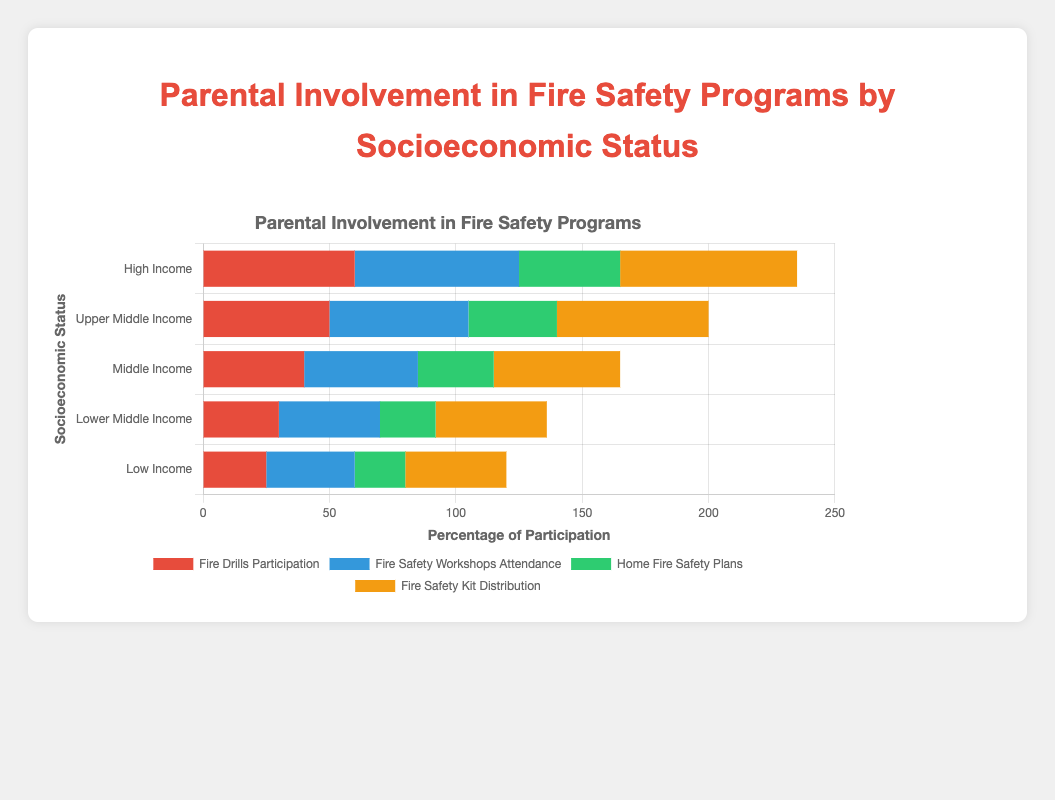Which socioeconomic status group has the highest participation in Fire Drills? Look at the data for Fire Drills Participation in the chart. The highest value is for High Income with a participation rate of 60%.
Answer: High Income Which activity has the most parental involvement across all socioeconomic statuses? To find the activity with the most involvement, sum the participation rates of each activity across all groups: Fire Drills (25+30+40+50+60), Fire Safety Workshops (35+40+45+55+65), Home Fire Safety Plans (20+22+30+35+40), Fire Safety Kit Distribution (40+44+50+60+70). Fire Safety Kit Distribution has the highest total with 264.
Answer: Fire Safety Kit Distribution Compare the Fire Safety Workshops Attendance between the Low Income and High Income groups. Which has a higher rate and by how much? Compare the values for Fire Safety Workshops Attendance in both groups: Low Income (35) and High Income (65). The difference is 65 - 35 = 30. High Income has a higher rate by 30%.
Answer: High Income, by 30% What is the total percentage of participation in all activities for the Middle Income group? Sum the percentages for all activities in the Middle Income group: 40 (Fire Drills) + 45 (Fire Safety Workshops) + 30 (Home Fire Safety Plans) + 50 (Fire Safety Kit Distribution). The total is 165%.
Answer: 165% Which socioeconomic status group has the smallest difference between Fire Drills Participation and Fire Safety Workshops Attendance? Calculate the difference between Fire Drills Participation and Fire Safety Workshops Attendance for each group: Low Income (10), Lower Middle Income (10), Middle Income (5), Upper Middle Income (5), High Income (5). Middle, Upper Middle, and High Income groups have the smallest difference of 5%.
Answer: Middle Income, Upper Middle Income, and High Income (tie) What is the average participation rate in Home Fire Safety Plans across all socioeconomic statuses? Sum the participation rates for Home Fire Safety Plans across all groups: 20 (Low Income) + 22 (Lower Middle Income) + 30 (Middle Income) + 35 (Upper Middle Income) + 40 (High Income). There are 5 groups, so divide the total by 5: (20+22+30+35+40)/5 = 29.4%.
Answer: 29.4% What is the combined percentage of Fire Safety Workshops Attendance and Fire Safety Kit Distribution for the Lower Middle Income group? For the Lower Middle Income group, sum the percentages for the two activities: 40 (Fire Safety Workshops) + 44 (Fire Safety Kit Distribution). The combined percentage is 84%.
Answer: 84% 